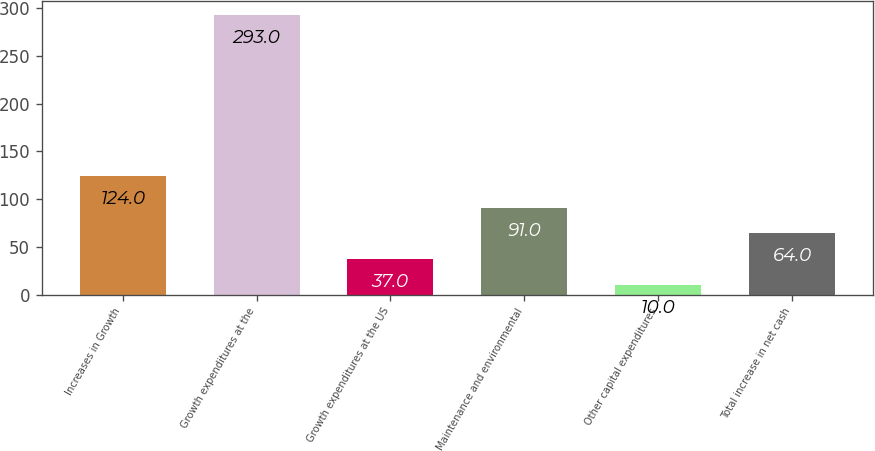Convert chart. <chart><loc_0><loc_0><loc_500><loc_500><bar_chart><fcel>Increases in Growth<fcel>Growth expenditures at the<fcel>Growth expenditures at the US<fcel>Maintenance and environmental<fcel>Other capital expenditures<fcel>Total increase in net cash<nl><fcel>124<fcel>293<fcel>37<fcel>91<fcel>10<fcel>64<nl></chart> 